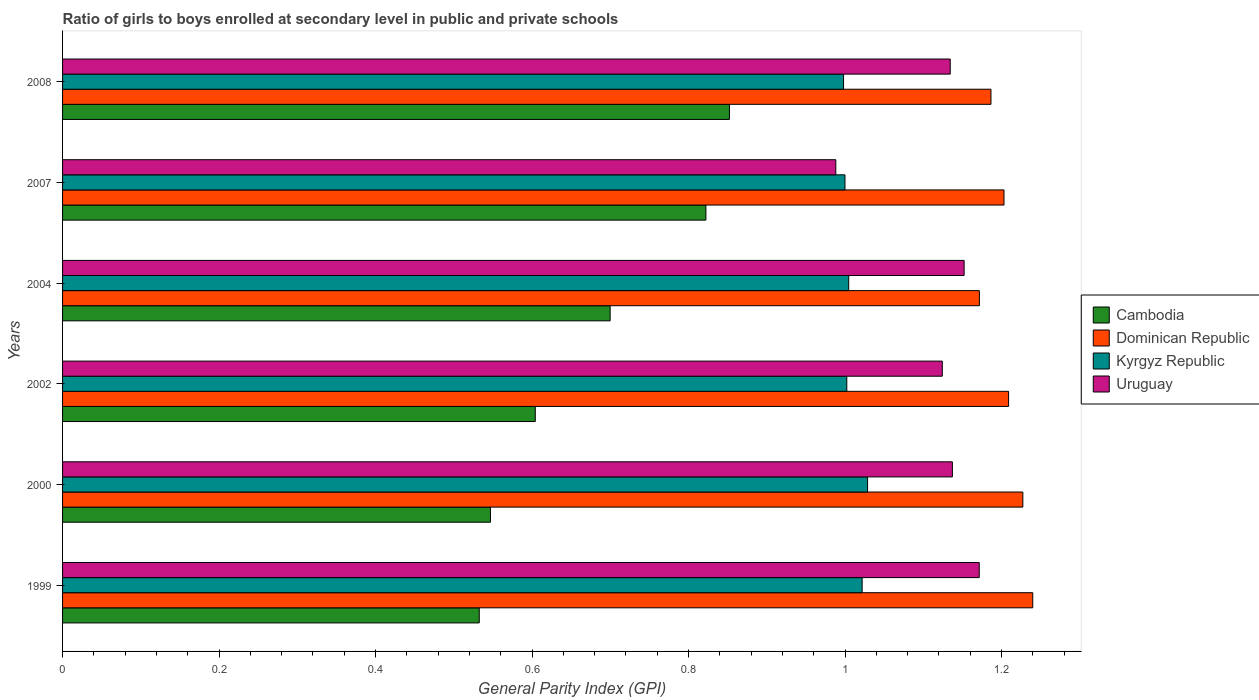How many different coloured bars are there?
Give a very brief answer. 4. Are the number of bars on each tick of the Y-axis equal?
Your response must be concise. Yes. How many bars are there on the 5th tick from the top?
Your response must be concise. 4. How many bars are there on the 1st tick from the bottom?
Provide a short and direct response. 4. What is the general parity index in Kyrgyz Republic in 1999?
Keep it short and to the point. 1.02. Across all years, what is the maximum general parity index in Cambodia?
Your response must be concise. 0.85. Across all years, what is the minimum general parity index in Cambodia?
Make the answer very short. 0.53. What is the total general parity index in Kyrgyz Republic in the graph?
Offer a very short reply. 6.06. What is the difference between the general parity index in Dominican Republic in 2002 and that in 2007?
Provide a succinct answer. 0.01. What is the difference between the general parity index in Kyrgyz Republic in 2004 and the general parity index in Uruguay in 1999?
Offer a terse response. -0.17. What is the average general parity index in Dominican Republic per year?
Offer a terse response. 1.21. In the year 2000, what is the difference between the general parity index in Dominican Republic and general parity index in Cambodia?
Make the answer very short. 0.68. In how many years, is the general parity index in Dominican Republic greater than 0.36 ?
Your answer should be compact. 6. What is the ratio of the general parity index in Dominican Republic in 2004 to that in 2008?
Give a very brief answer. 0.99. Is the general parity index in Dominican Republic in 2000 less than that in 2004?
Give a very brief answer. No. What is the difference between the highest and the second highest general parity index in Dominican Republic?
Your response must be concise. 0.01. What is the difference between the highest and the lowest general parity index in Kyrgyz Republic?
Keep it short and to the point. 0.03. In how many years, is the general parity index in Cambodia greater than the average general parity index in Cambodia taken over all years?
Keep it short and to the point. 3. Is the sum of the general parity index in Uruguay in 2004 and 2008 greater than the maximum general parity index in Dominican Republic across all years?
Provide a succinct answer. Yes. Is it the case that in every year, the sum of the general parity index in Cambodia and general parity index in Dominican Republic is greater than the sum of general parity index in Uruguay and general parity index in Kyrgyz Republic?
Offer a terse response. Yes. What does the 2nd bar from the top in 2007 represents?
Offer a very short reply. Kyrgyz Republic. What does the 3rd bar from the bottom in 2002 represents?
Give a very brief answer. Kyrgyz Republic. Is it the case that in every year, the sum of the general parity index in Dominican Republic and general parity index in Uruguay is greater than the general parity index in Cambodia?
Make the answer very short. Yes. How many bars are there?
Make the answer very short. 24. Are all the bars in the graph horizontal?
Give a very brief answer. Yes. What is the difference between two consecutive major ticks on the X-axis?
Your response must be concise. 0.2. What is the title of the graph?
Provide a short and direct response. Ratio of girls to boys enrolled at secondary level in public and private schools. What is the label or title of the X-axis?
Ensure brevity in your answer.  General Parity Index (GPI). What is the label or title of the Y-axis?
Make the answer very short. Years. What is the General Parity Index (GPI) of Cambodia in 1999?
Your response must be concise. 0.53. What is the General Parity Index (GPI) in Dominican Republic in 1999?
Your answer should be compact. 1.24. What is the General Parity Index (GPI) in Kyrgyz Republic in 1999?
Provide a short and direct response. 1.02. What is the General Parity Index (GPI) in Uruguay in 1999?
Your response must be concise. 1.17. What is the General Parity Index (GPI) in Cambodia in 2000?
Make the answer very short. 0.55. What is the General Parity Index (GPI) in Dominican Republic in 2000?
Provide a succinct answer. 1.23. What is the General Parity Index (GPI) of Kyrgyz Republic in 2000?
Keep it short and to the point. 1.03. What is the General Parity Index (GPI) of Uruguay in 2000?
Your answer should be very brief. 1.14. What is the General Parity Index (GPI) of Cambodia in 2002?
Your response must be concise. 0.6. What is the General Parity Index (GPI) of Dominican Republic in 2002?
Give a very brief answer. 1.21. What is the General Parity Index (GPI) of Kyrgyz Republic in 2002?
Provide a succinct answer. 1. What is the General Parity Index (GPI) in Uruguay in 2002?
Offer a very short reply. 1.12. What is the General Parity Index (GPI) of Cambodia in 2004?
Provide a short and direct response. 0.7. What is the General Parity Index (GPI) of Dominican Republic in 2004?
Offer a terse response. 1.17. What is the General Parity Index (GPI) in Kyrgyz Republic in 2004?
Give a very brief answer. 1. What is the General Parity Index (GPI) of Uruguay in 2004?
Your answer should be compact. 1.15. What is the General Parity Index (GPI) in Cambodia in 2007?
Your response must be concise. 0.82. What is the General Parity Index (GPI) in Dominican Republic in 2007?
Provide a short and direct response. 1.2. What is the General Parity Index (GPI) in Kyrgyz Republic in 2007?
Provide a short and direct response. 1. What is the General Parity Index (GPI) in Uruguay in 2007?
Make the answer very short. 0.99. What is the General Parity Index (GPI) in Cambodia in 2008?
Your answer should be compact. 0.85. What is the General Parity Index (GPI) of Dominican Republic in 2008?
Your answer should be very brief. 1.19. What is the General Parity Index (GPI) in Kyrgyz Republic in 2008?
Give a very brief answer. 1. What is the General Parity Index (GPI) of Uruguay in 2008?
Offer a very short reply. 1.13. Across all years, what is the maximum General Parity Index (GPI) of Cambodia?
Provide a succinct answer. 0.85. Across all years, what is the maximum General Parity Index (GPI) of Dominican Republic?
Your answer should be very brief. 1.24. Across all years, what is the maximum General Parity Index (GPI) of Kyrgyz Republic?
Your answer should be very brief. 1.03. Across all years, what is the maximum General Parity Index (GPI) in Uruguay?
Offer a terse response. 1.17. Across all years, what is the minimum General Parity Index (GPI) of Cambodia?
Keep it short and to the point. 0.53. Across all years, what is the minimum General Parity Index (GPI) in Dominican Republic?
Your answer should be very brief. 1.17. Across all years, what is the minimum General Parity Index (GPI) in Kyrgyz Republic?
Offer a terse response. 1. Across all years, what is the minimum General Parity Index (GPI) of Uruguay?
Your answer should be compact. 0.99. What is the total General Parity Index (GPI) in Cambodia in the graph?
Keep it short and to the point. 4.06. What is the total General Parity Index (GPI) of Dominican Republic in the graph?
Your response must be concise. 7.24. What is the total General Parity Index (GPI) of Kyrgyz Republic in the graph?
Your answer should be very brief. 6.06. What is the total General Parity Index (GPI) in Uruguay in the graph?
Your answer should be very brief. 6.71. What is the difference between the General Parity Index (GPI) of Cambodia in 1999 and that in 2000?
Your response must be concise. -0.01. What is the difference between the General Parity Index (GPI) of Dominican Republic in 1999 and that in 2000?
Provide a short and direct response. 0.01. What is the difference between the General Parity Index (GPI) of Kyrgyz Republic in 1999 and that in 2000?
Offer a terse response. -0.01. What is the difference between the General Parity Index (GPI) of Uruguay in 1999 and that in 2000?
Offer a very short reply. 0.03. What is the difference between the General Parity Index (GPI) of Cambodia in 1999 and that in 2002?
Provide a short and direct response. -0.07. What is the difference between the General Parity Index (GPI) in Dominican Republic in 1999 and that in 2002?
Offer a terse response. 0.03. What is the difference between the General Parity Index (GPI) of Kyrgyz Republic in 1999 and that in 2002?
Your answer should be very brief. 0.02. What is the difference between the General Parity Index (GPI) in Uruguay in 1999 and that in 2002?
Offer a very short reply. 0.05. What is the difference between the General Parity Index (GPI) of Cambodia in 1999 and that in 2004?
Give a very brief answer. -0.17. What is the difference between the General Parity Index (GPI) of Dominican Republic in 1999 and that in 2004?
Make the answer very short. 0.07. What is the difference between the General Parity Index (GPI) in Kyrgyz Republic in 1999 and that in 2004?
Make the answer very short. 0.02. What is the difference between the General Parity Index (GPI) of Uruguay in 1999 and that in 2004?
Provide a succinct answer. 0.02. What is the difference between the General Parity Index (GPI) in Cambodia in 1999 and that in 2007?
Make the answer very short. -0.29. What is the difference between the General Parity Index (GPI) in Dominican Republic in 1999 and that in 2007?
Your answer should be very brief. 0.04. What is the difference between the General Parity Index (GPI) of Kyrgyz Republic in 1999 and that in 2007?
Give a very brief answer. 0.02. What is the difference between the General Parity Index (GPI) in Uruguay in 1999 and that in 2007?
Offer a very short reply. 0.18. What is the difference between the General Parity Index (GPI) in Cambodia in 1999 and that in 2008?
Give a very brief answer. -0.32. What is the difference between the General Parity Index (GPI) of Dominican Republic in 1999 and that in 2008?
Give a very brief answer. 0.05. What is the difference between the General Parity Index (GPI) of Kyrgyz Republic in 1999 and that in 2008?
Your answer should be very brief. 0.02. What is the difference between the General Parity Index (GPI) in Uruguay in 1999 and that in 2008?
Give a very brief answer. 0.04. What is the difference between the General Parity Index (GPI) of Cambodia in 2000 and that in 2002?
Offer a terse response. -0.06. What is the difference between the General Parity Index (GPI) of Dominican Republic in 2000 and that in 2002?
Ensure brevity in your answer.  0.02. What is the difference between the General Parity Index (GPI) of Kyrgyz Republic in 2000 and that in 2002?
Offer a very short reply. 0.03. What is the difference between the General Parity Index (GPI) of Uruguay in 2000 and that in 2002?
Keep it short and to the point. 0.01. What is the difference between the General Parity Index (GPI) of Cambodia in 2000 and that in 2004?
Your answer should be compact. -0.15. What is the difference between the General Parity Index (GPI) in Dominican Republic in 2000 and that in 2004?
Keep it short and to the point. 0.06. What is the difference between the General Parity Index (GPI) of Kyrgyz Republic in 2000 and that in 2004?
Offer a very short reply. 0.02. What is the difference between the General Parity Index (GPI) of Uruguay in 2000 and that in 2004?
Keep it short and to the point. -0.01. What is the difference between the General Parity Index (GPI) of Cambodia in 2000 and that in 2007?
Ensure brevity in your answer.  -0.28. What is the difference between the General Parity Index (GPI) of Dominican Republic in 2000 and that in 2007?
Provide a succinct answer. 0.02. What is the difference between the General Parity Index (GPI) of Kyrgyz Republic in 2000 and that in 2007?
Provide a short and direct response. 0.03. What is the difference between the General Parity Index (GPI) of Uruguay in 2000 and that in 2007?
Keep it short and to the point. 0.15. What is the difference between the General Parity Index (GPI) of Cambodia in 2000 and that in 2008?
Your answer should be very brief. -0.31. What is the difference between the General Parity Index (GPI) in Dominican Republic in 2000 and that in 2008?
Offer a very short reply. 0.04. What is the difference between the General Parity Index (GPI) of Kyrgyz Republic in 2000 and that in 2008?
Make the answer very short. 0.03. What is the difference between the General Parity Index (GPI) of Uruguay in 2000 and that in 2008?
Provide a succinct answer. 0. What is the difference between the General Parity Index (GPI) in Cambodia in 2002 and that in 2004?
Offer a very short reply. -0.1. What is the difference between the General Parity Index (GPI) of Dominican Republic in 2002 and that in 2004?
Your answer should be very brief. 0.04. What is the difference between the General Parity Index (GPI) of Kyrgyz Republic in 2002 and that in 2004?
Offer a very short reply. -0. What is the difference between the General Parity Index (GPI) of Uruguay in 2002 and that in 2004?
Provide a succinct answer. -0.03. What is the difference between the General Parity Index (GPI) of Cambodia in 2002 and that in 2007?
Give a very brief answer. -0.22. What is the difference between the General Parity Index (GPI) in Dominican Republic in 2002 and that in 2007?
Offer a terse response. 0.01. What is the difference between the General Parity Index (GPI) in Kyrgyz Republic in 2002 and that in 2007?
Provide a succinct answer. 0. What is the difference between the General Parity Index (GPI) of Uruguay in 2002 and that in 2007?
Offer a terse response. 0.14. What is the difference between the General Parity Index (GPI) of Cambodia in 2002 and that in 2008?
Provide a short and direct response. -0.25. What is the difference between the General Parity Index (GPI) in Dominican Republic in 2002 and that in 2008?
Your answer should be compact. 0.02. What is the difference between the General Parity Index (GPI) in Kyrgyz Republic in 2002 and that in 2008?
Your response must be concise. 0. What is the difference between the General Parity Index (GPI) of Uruguay in 2002 and that in 2008?
Offer a terse response. -0.01. What is the difference between the General Parity Index (GPI) in Cambodia in 2004 and that in 2007?
Your answer should be very brief. -0.12. What is the difference between the General Parity Index (GPI) of Dominican Republic in 2004 and that in 2007?
Offer a terse response. -0.03. What is the difference between the General Parity Index (GPI) of Kyrgyz Republic in 2004 and that in 2007?
Make the answer very short. 0. What is the difference between the General Parity Index (GPI) in Uruguay in 2004 and that in 2007?
Offer a terse response. 0.16. What is the difference between the General Parity Index (GPI) in Cambodia in 2004 and that in 2008?
Give a very brief answer. -0.15. What is the difference between the General Parity Index (GPI) in Dominican Republic in 2004 and that in 2008?
Provide a succinct answer. -0.01. What is the difference between the General Parity Index (GPI) in Kyrgyz Republic in 2004 and that in 2008?
Your answer should be compact. 0.01. What is the difference between the General Parity Index (GPI) of Uruguay in 2004 and that in 2008?
Offer a terse response. 0.02. What is the difference between the General Parity Index (GPI) of Cambodia in 2007 and that in 2008?
Keep it short and to the point. -0.03. What is the difference between the General Parity Index (GPI) of Dominican Republic in 2007 and that in 2008?
Make the answer very short. 0.02. What is the difference between the General Parity Index (GPI) in Kyrgyz Republic in 2007 and that in 2008?
Make the answer very short. 0. What is the difference between the General Parity Index (GPI) of Uruguay in 2007 and that in 2008?
Your response must be concise. -0.15. What is the difference between the General Parity Index (GPI) of Cambodia in 1999 and the General Parity Index (GPI) of Dominican Republic in 2000?
Offer a terse response. -0.69. What is the difference between the General Parity Index (GPI) in Cambodia in 1999 and the General Parity Index (GPI) in Kyrgyz Republic in 2000?
Give a very brief answer. -0.5. What is the difference between the General Parity Index (GPI) in Cambodia in 1999 and the General Parity Index (GPI) in Uruguay in 2000?
Your response must be concise. -0.6. What is the difference between the General Parity Index (GPI) of Dominican Republic in 1999 and the General Parity Index (GPI) of Kyrgyz Republic in 2000?
Your answer should be very brief. 0.21. What is the difference between the General Parity Index (GPI) of Dominican Republic in 1999 and the General Parity Index (GPI) of Uruguay in 2000?
Make the answer very short. 0.1. What is the difference between the General Parity Index (GPI) in Kyrgyz Republic in 1999 and the General Parity Index (GPI) in Uruguay in 2000?
Ensure brevity in your answer.  -0.12. What is the difference between the General Parity Index (GPI) in Cambodia in 1999 and the General Parity Index (GPI) in Dominican Republic in 2002?
Your answer should be very brief. -0.68. What is the difference between the General Parity Index (GPI) of Cambodia in 1999 and the General Parity Index (GPI) of Kyrgyz Republic in 2002?
Provide a succinct answer. -0.47. What is the difference between the General Parity Index (GPI) of Cambodia in 1999 and the General Parity Index (GPI) of Uruguay in 2002?
Your answer should be compact. -0.59. What is the difference between the General Parity Index (GPI) of Dominican Republic in 1999 and the General Parity Index (GPI) of Kyrgyz Republic in 2002?
Give a very brief answer. 0.24. What is the difference between the General Parity Index (GPI) of Dominican Republic in 1999 and the General Parity Index (GPI) of Uruguay in 2002?
Ensure brevity in your answer.  0.12. What is the difference between the General Parity Index (GPI) of Kyrgyz Republic in 1999 and the General Parity Index (GPI) of Uruguay in 2002?
Make the answer very short. -0.1. What is the difference between the General Parity Index (GPI) in Cambodia in 1999 and the General Parity Index (GPI) in Dominican Republic in 2004?
Ensure brevity in your answer.  -0.64. What is the difference between the General Parity Index (GPI) in Cambodia in 1999 and the General Parity Index (GPI) in Kyrgyz Republic in 2004?
Provide a short and direct response. -0.47. What is the difference between the General Parity Index (GPI) in Cambodia in 1999 and the General Parity Index (GPI) in Uruguay in 2004?
Your answer should be very brief. -0.62. What is the difference between the General Parity Index (GPI) in Dominican Republic in 1999 and the General Parity Index (GPI) in Kyrgyz Republic in 2004?
Keep it short and to the point. 0.24. What is the difference between the General Parity Index (GPI) in Dominican Republic in 1999 and the General Parity Index (GPI) in Uruguay in 2004?
Give a very brief answer. 0.09. What is the difference between the General Parity Index (GPI) in Kyrgyz Republic in 1999 and the General Parity Index (GPI) in Uruguay in 2004?
Make the answer very short. -0.13. What is the difference between the General Parity Index (GPI) in Cambodia in 1999 and the General Parity Index (GPI) in Dominican Republic in 2007?
Provide a short and direct response. -0.67. What is the difference between the General Parity Index (GPI) in Cambodia in 1999 and the General Parity Index (GPI) in Kyrgyz Republic in 2007?
Your answer should be very brief. -0.47. What is the difference between the General Parity Index (GPI) in Cambodia in 1999 and the General Parity Index (GPI) in Uruguay in 2007?
Provide a succinct answer. -0.46. What is the difference between the General Parity Index (GPI) in Dominican Republic in 1999 and the General Parity Index (GPI) in Kyrgyz Republic in 2007?
Your response must be concise. 0.24. What is the difference between the General Parity Index (GPI) of Dominican Republic in 1999 and the General Parity Index (GPI) of Uruguay in 2007?
Provide a succinct answer. 0.25. What is the difference between the General Parity Index (GPI) in Kyrgyz Republic in 1999 and the General Parity Index (GPI) in Uruguay in 2007?
Your response must be concise. 0.03. What is the difference between the General Parity Index (GPI) in Cambodia in 1999 and the General Parity Index (GPI) in Dominican Republic in 2008?
Offer a terse response. -0.65. What is the difference between the General Parity Index (GPI) in Cambodia in 1999 and the General Parity Index (GPI) in Kyrgyz Republic in 2008?
Your answer should be very brief. -0.47. What is the difference between the General Parity Index (GPI) in Cambodia in 1999 and the General Parity Index (GPI) in Uruguay in 2008?
Your response must be concise. -0.6. What is the difference between the General Parity Index (GPI) in Dominican Republic in 1999 and the General Parity Index (GPI) in Kyrgyz Republic in 2008?
Provide a succinct answer. 0.24. What is the difference between the General Parity Index (GPI) of Dominican Republic in 1999 and the General Parity Index (GPI) of Uruguay in 2008?
Offer a terse response. 0.11. What is the difference between the General Parity Index (GPI) in Kyrgyz Republic in 1999 and the General Parity Index (GPI) in Uruguay in 2008?
Give a very brief answer. -0.11. What is the difference between the General Parity Index (GPI) in Cambodia in 2000 and the General Parity Index (GPI) in Dominican Republic in 2002?
Provide a succinct answer. -0.66. What is the difference between the General Parity Index (GPI) in Cambodia in 2000 and the General Parity Index (GPI) in Kyrgyz Republic in 2002?
Keep it short and to the point. -0.46. What is the difference between the General Parity Index (GPI) in Cambodia in 2000 and the General Parity Index (GPI) in Uruguay in 2002?
Your answer should be compact. -0.58. What is the difference between the General Parity Index (GPI) of Dominican Republic in 2000 and the General Parity Index (GPI) of Kyrgyz Republic in 2002?
Keep it short and to the point. 0.23. What is the difference between the General Parity Index (GPI) of Dominican Republic in 2000 and the General Parity Index (GPI) of Uruguay in 2002?
Your answer should be very brief. 0.1. What is the difference between the General Parity Index (GPI) in Kyrgyz Republic in 2000 and the General Parity Index (GPI) in Uruguay in 2002?
Give a very brief answer. -0.1. What is the difference between the General Parity Index (GPI) in Cambodia in 2000 and the General Parity Index (GPI) in Dominican Republic in 2004?
Keep it short and to the point. -0.62. What is the difference between the General Parity Index (GPI) of Cambodia in 2000 and the General Parity Index (GPI) of Kyrgyz Republic in 2004?
Offer a very short reply. -0.46. What is the difference between the General Parity Index (GPI) in Cambodia in 2000 and the General Parity Index (GPI) in Uruguay in 2004?
Ensure brevity in your answer.  -0.61. What is the difference between the General Parity Index (GPI) of Dominican Republic in 2000 and the General Parity Index (GPI) of Kyrgyz Republic in 2004?
Offer a terse response. 0.22. What is the difference between the General Parity Index (GPI) in Dominican Republic in 2000 and the General Parity Index (GPI) in Uruguay in 2004?
Give a very brief answer. 0.07. What is the difference between the General Parity Index (GPI) in Kyrgyz Republic in 2000 and the General Parity Index (GPI) in Uruguay in 2004?
Provide a succinct answer. -0.12. What is the difference between the General Parity Index (GPI) of Cambodia in 2000 and the General Parity Index (GPI) of Dominican Republic in 2007?
Provide a succinct answer. -0.66. What is the difference between the General Parity Index (GPI) of Cambodia in 2000 and the General Parity Index (GPI) of Kyrgyz Republic in 2007?
Your answer should be compact. -0.45. What is the difference between the General Parity Index (GPI) of Cambodia in 2000 and the General Parity Index (GPI) of Uruguay in 2007?
Give a very brief answer. -0.44. What is the difference between the General Parity Index (GPI) in Dominican Republic in 2000 and the General Parity Index (GPI) in Kyrgyz Republic in 2007?
Your response must be concise. 0.23. What is the difference between the General Parity Index (GPI) of Dominican Republic in 2000 and the General Parity Index (GPI) of Uruguay in 2007?
Ensure brevity in your answer.  0.24. What is the difference between the General Parity Index (GPI) in Kyrgyz Republic in 2000 and the General Parity Index (GPI) in Uruguay in 2007?
Give a very brief answer. 0.04. What is the difference between the General Parity Index (GPI) of Cambodia in 2000 and the General Parity Index (GPI) of Dominican Republic in 2008?
Give a very brief answer. -0.64. What is the difference between the General Parity Index (GPI) of Cambodia in 2000 and the General Parity Index (GPI) of Kyrgyz Republic in 2008?
Ensure brevity in your answer.  -0.45. What is the difference between the General Parity Index (GPI) of Cambodia in 2000 and the General Parity Index (GPI) of Uruguay in 2008?
Offer a terse response. -0.59. What is the difference between the General Parity Index (GPI) of Dominican Republic in 2000 and the General Parity Index (GPI) of Kyrgyz Republic in 2008?
Keep it short and to the point. 0.23. What is the difference between the General Parity Index (GPI) in Dominican Republic in 2000 and the General Parity Index (GPI) in Uruguay in 2008?
Make the answer very short. 0.09. What is the difference between the General Parity Index (GPI) of Kyrgyz Republic in 2000 and the General Parity Index (GPI) of Uruguay in 2008?
Give a very brief answer. -0.11. What is the difference between the General Parity Index (GPI) in Cambodia in 2002 and the General Parity Index (GPI) in Dominican Republic in 2004?
Offer a very short reply. -0.57. What is the difference between the General Parity Index (GPI) of Cambodia in 2002 and the General Parity Index (GPI) of Kyrgyz Republic in 2004?
Offer a very short reply. -0.4. What is the difference between the General Parity Index (GPI) of Cambodia in 2002 and the General Parity Index (GPI) of Uruguay in 2004?
Your answer should be compact. -0.55. What is the difference between the General Parity Index (GPI) of Dominican Republic in 2002 and the General Parity Index (GPI) of Kyrgyz Republic in 2004?
Provide a succinct answer. 0.2. What is the difference between the General Parity Index (GPI) in Dominican Republic in 2002 and the General Parity Index (GPI) in Uruguay in 2004?
Offer a terse response. 0.06. What is the difference between the General Parity Index (GPI) in Kyrgyz Republic in 2002 and the General Parity Index (GPI) in Uruguay in 2004?
Your response must be concise. -0.15. What is the difference between the General Parity Index (GPI) in Cambodia in 2002 and the General Parity Index (GPI) in Dominican Republic in 2007?
Your answer should be compact. -0.6. What is the difference between the General Parity Index (GPI) of Cambodia in 2002 and the General Parity Index (GPI) of Kyrgyz Republic in 2007?
Ensure brevity in your answer.  -0.4. What is the difference between the General Parity Index (GPI) of Cambodia in 2002 and the General Parity Index (GPI) of Uruguay in 2007?
Offer a very short reply. -0.38. What is the difference between the General Parity Index (GPI) of Dominican Republic in 2002 and the General Parity Index (GPI) of Kyrgyz Republic in 2007?
Your answer should be compact. 0.21. What is the difference between the General Parity Index (GPI) in Dominican Republic in 2002 and the General Parity Index (GPI) in Uruguay in 2007?
Your response must be concise. 0.22. What is the difference between the General Parity Index (GPI) in Kyrgyz Republic in 2002 and the General Parity Index (GPI) in Uruguay in 2007?
Make the answer very short. 0.01. What is the difference between the General Parity Index (GPI) in Cambodia in 2002 and the General Parity Index (GPI) in Dominican Republic in 2008?
Offer a very short reply. -0.58. What is the difference between the General Parity Index (GPI) in Cambodia in 2002 and the General Parity Index (GPI) in Kyrgyz Republic in 2008?
Make the answer very short. -0.39. What is the difference between the General Parity Index (GPI) in Cambodia in 2002 and the General Parity Index (GPI) in Uruguay in 2008?
Provide a succinct answer. -0.53. What is the difference between the General Parity Index (GPI) in Dominican Republic in 2002 and the General Parity Index (GPI) in Kyrgyz Republic in 2008?
Your answer should be very brief. 0.21. What is the difference between the General Parity Index (GPI) of Dominican Republic in 2002 and the General Parity Index (GPI) of Uruguay in 2008?
Offer a very short reply. 0.07. What is the difference between the General Parity Index (GPI) in Kyrgyz Republic in 2002 and the General Parity Index (GPI) in Uruguay in 2008?
Offer a very short reply. -0.13. What is the difference between the General Parity Index (GPI) of Cambodia in 2004 and the General Parity Index (GPI) of Dominican Republic in 2007?
Provide a succinct answer. -0.5. What is the difference between the General Parity Index (GPI) of Cambodia in 2004 and the General Parity Index (GPI) of Kyrgyz Republic in 2007?
Give a very brief answer. -0.3. What is the difference between the General Parity Index (GPI) in Cambodia in 2004 and the General Parity Index (GPI) in Uruguay in 2007?
Keep it short and to the point. -0.29. What is the difference between the General Parity Index (GPI) in Dominican Republic in 2004 and the General Parity Index (GPI) in Kyrgyz Republic in 2007?
Make the answer very short. 0.17. What is the difference between the General Parity Index (GPI) of Dominican Republic in 2004 and the General Parity Index (GPI) of Uruguay in 2007?
Give a very brief answer. 0.18. What is the difference between the General Parity Index (GPI) in Kyrgyz Republic in 2004 and the General Parity Index (GPI) in Uruguay in 2007?
Provide a succinct answer. 0.02. What is the difference between the General Parity Index (GPI) of Cambodia in 2004 and the General Parity Index (GPI) of Dominican Republic in 2008?
Your answer should be very brief. -0.49. What is the difference between the General Parity Index (GPI) in Cambodia in 2004 and the General Parity Index (GPI) in Kyrgyz Republic in 2008?
Give a very brief answer. -0.3. What is the difference between the General Parity Index (GPI) of Cambodia in 2004 and the General Parity Index (GPI) of Uruguay in 2008?
Offer a very short reply. -0.43. What is the difference between the General Parity Index (GPI) of Dominican Republic in 2004 and the General Parity Index (GPI) of Kyrgyz Republic in 2008?
Provide a succinct answer. 0.17. What is the difference between the General Parity Index (GPI) of Dominican Republic in 2004 and the General Parity Index (GPI) of Uruguay in 2008?
Offer a very short reply. 0.04. What is the difference between the General Parity Index (GPI) of Kyrgyz Republic in 2004 and the General Parity Index (GPI) of Uruguay in 2008?
Your answer should be very brief. -0.13. What is the difference between the General Parity Index (GPI) of Cambodia in 2007 and the General Parity Index (GPI) of Dominican Republic in 2008?
Your response must be concise. -0.36. What is the difference between the General Parity Index (GPI) of Cambodia in 2007 and the General Parity Index (GPI) of Kyrgyz Republic in 2008?
Keep it short and to the point. -0.18. What is the difference between the General Parity Index (GPI) of Cambodia in 2007 and the General Parity Index (GPI) of Uruguay in 2008?
Keep it short and to the point. -0.31. What is the difference between the General Parity Index (GPI) in Dominican Republic in 2007 and the General Parity Index (GPI) in Kyrgyz Republic in 2008?
Give a very brief answer. 0.2. What is the difference between the General Parity Index (GPI) of Dominican Republic in 2007 and the General Parity Index (GPI) of Uruguay in 2008?
Provide a succinct answer. 0.07. What is the difference between the General Parity Index (GPI) of Kyrgyz Republic in 2007 and the General Parity Index (GPI) of Uruguay in 2008?
Offer a very short reply. -0.13. What is the average General Parity Index (GPI) in Cambodia per year?
Provide a short and direct response. 0.68. What is the average General Parity Index (GPI) of Dominican Republic per year?
Keep it short and to the point. 1.21. What is the average General Parity Index (GPI) of Kyrgyz Republic per year?
Ensure brevity in your answer.  1.01. What is the average General Parity Index (GPI) in Uruguay per year?
Offer a very short reply. 1.12. In the year 1999, what is the difference between the General Parity Index (GPI) in Cambodia and General Parity Index (GPI) in Dominican Republic?
Make the answer very short. -0.71. In the year 1999, what is the difference between the General Parity Index (GPI) in Cambodia and General Parity Index (GPI) in Kyrgyz Republic?
Offer a terse response. -0.49. In the year 1999, what is the difference between the General Parity Index (GPI) of Cambodia and General Parity Index (GPI) of Uruguay?
Make the answer very short. -0.64. In the year 1999, what is the difference between the General Parity Index (GPI) in Dominican Republic and General Parity Index (GPI) in Kyrgyz Republic?
Your response must be concise. 0.22. In the year 1999, what is the difference between the General Parity Index (GPI) in Dominican Republic and General Parity Index (GPI) in Uruguay?
Your response must be concise. 0.07. In the year 1999, what is the difference between the General Parity Index (GPI) in Kyrgyz Republic and General Parity Index (GPI) in Uruguay?
Your answer should be compact. -0.15. In the year 2000, what is the difference between the General Parity Index (GPI) in Cambodia and General Parity Index (GPI) in Dominican Republic?
Your response must be concise. -0.68. In the year 2000, what is the difference between the General Parity Index (GPI) of Cambodia and General Parity Index (GPI) of Kyrgyz Republic?
Offer a terse response. -0.48. In the year 2000, what is the difference between the General Parity Index (GPI) of Cambodia and General Parity Index (GPI) of Uruguay?
Offer a terse response. -0.59. In the year 2000, what is the difference between the General Parity Index (GPI) of Dominican Republic and General Parity Index (GPI) of Kyrgyz Republic?
Ensure brevity in your answer.  0.2. In the year 2000, what is the difference between the General Parity Index (GPI) of Dominican Republic and General Parity Index (GPI) of Uruguay?
Ensure brevity in your answer.  0.09. In the year 2000, what is the difference between the General Parity Index (GPI) in Kyrgyz Republic and General Parity Index (GPI) in Uruguay?
Give a very brief answer. -0.11. In the year 2002, what is the difference between the General Parity Index (GPI) of Cambodia and General Parity Index (GPI) of Dominican Republic?
Offer a terse response. -0.6. In the year 2002, what is the difference between the General Parity Index (GPI) of Cambodia and General Parity Index (GPI) of Kyrgyz Republic?
Your answer should be compact. -0.4. In the year 2002, what is the difference between the General Parity Index (GPI) of Cambodia and General Parity Index (GPI) of Uruguay?
Provide a succinct answer. -0.52. In the year 2002, what is the difference between the General Parity Index (GPI) of Dominican Republic and General Parity Index (GPI) of Kyrgyz Republic?
Ensure brevity in your answer.  0.21. In the year 2002, what is the difference between the General Parity Index (GPI) in Dominican Republic and General Parity Index (GPI) in Uruguay?
Keep it short and to the point. 0.08. In the year 2002, what is the difference between the General Parity Index (GPI) in Kyrgyz Republic and General Parity Index (GPI) in Uruguay?
Provide a short and direct response. -0.12. In the year 2004, what is the difference between the General Parity Index (GPI) of Cambodia and General Parity Index (GPI) of Dominican Republic?
Provide a succinct answer. -0.47. In the year 2004, what is the difference between the General Parity Index (GPI) of Cambodia and General Parity Index (GPI) of Kyrgyz Republic?
Your answer should be compact. -0.3. In the year 2004, what is the difference between the General Parity Index (GPI) in Cambodia and General Parity Index (GPI) in Uruguay?
Provide a short and direct response. -0.45. In the year 2004, what is the difference between the General Parity Index (GPI) of Dominican Republic and General Parity Index (GPI) of Kyrgyz Republic?
Offer a terse response. 0.17. In the year 2004, what is the difference between the General Parity Index (GPI) in Dominican Republic and General Parity Index (GPI) in Uruguay?
Your answer should be compact. 0.02. In the year 2004, what is the difference between the General Parity Index (GPI) of Kyrgyz Republic and General Parity Index (GPI) of Uruguay?
Your answer should be compact. -0.15. In the year 2007, what is the difference between the General Parity Index (GPI) of Cambodia and General Parity Index (GPI) of Dominican Republic?
Provide a short and direct response. -0.38. In the year 2007, what is the difference between the General Parity Index (GPI) of Cambodia and General Parity Index (GPI) of Kyrgyz Republic?
Offer a very short reply. -0.18. In the year 2007, what is the difference between the General Parity Index (GPI) in Cambodia and General Parity Index (GPI) in Uruguay?
Make the answer very short. -0.17. In the year 2007, what is the difference between the General Parity Index (GPI) of Dominican Republic and General Parity Index (GPI) of Kyrgyz Republic?
Ensure brevity in your answer.  0.2. In the year 2007, what is the difference between the General Parity Index (GPI) in Dominican Republic and General Parity Index (GPI) in Uruguay?
Your answer should be compact. 0.21. In the year 2007, what is the difference between the General Parity Index (GPI) in Kyrgyz Republic and General Parity Index (GPI) in Uruguay?
Keep it short and to the point. 0.01. In the year 2008, what is the difference between the General Parity Index (GPI) of Cambodia and General Parity Index (GPI) of Dominican Republic?
Keep it short and to the point. -0.33. In the year 2008, what is the difference between the General Parity Index (GPI) in Cambodia and General Parity Index (GPI) in Kyrgyz Republic?
Offer a very short reply. -0.15. In the year 2008, what is the difference between the General Parity Index (GPI) of Cambodia and General Parity Index (GPI) of Uruguay?
Provide a succinct answer. -0.28. In the year 2008, what is the difference between the General Parity Index (GPI) of Dominican Republic and General Parity Index (GPI) of Kyrgyz Republic?
Offer a terse response. 0.19. In the year 2008, what is the difference between the General Parity Index (GPI) of Dominican Republic and General Parity Index (GPI) of Uruguay?
Provide a short and direct response. 0.05. In the year 2008, what is the difference between the General Parity Index (GPI) of Kyrgyz Republic and General Parity Index (GPI) of Uruguay?
Your answer should be compact. -0.14. What is the ratio of the General Parity Index (GPI) in Cambodia in 1999 to that in 2000?
Offer a terse response. 0.97. What is the ratio of the General Parity Index (GPI) in Dominican Republic in 1999 to that in 2000?
Your answer should be very brief. 1.01. What is the ratio of the General Parity Index (GPI) of Uruguay in 1999 to that in 2000?
Give a very brief answer. 1.03. What is the ratio of the General Parity Index (GPI) in Cambodia in 1999 to that in 2002?
Ensure brevity in your answer.  0.88. What is the ratio of the General Parity Index (GPI) of Dominican Republic in 1999 to that in 2002?
Your answer should be very brief. 1.03. What is the ratio of the General Parity Index (GPI) of Kyrgyz Republic in 1999 to that in 2002?
Offer a terse response. 1.02. What is the ratio of the General Parity Index (GPI) of Uruguay in 1999 to that in 2002?
Provide a short and direct response. 1.04. What is the ratio of the General Parity Index (GPI) in Cambodia in 1999 to that in 2004?
Give a very brief answer. 0.76. What is the ratio of the General Parity Index (GPI) of Dominican Republic in 1999 to that in 2004?
Provide a short and direct response. 1.06. What is the ratio of the General Parity Index (GPI) in Kyrgyz Republic in 1999 to that in 2004?
Ensure brevity in your answer.  1.02. What is the ratio of the General Parity Index (GPI) of Uruguay in 1999 to that in 2004?
Your response must be concise. 1.02. What is the ratio of the General Parity Index (GPI) of Cambodia in 1999 to that in 2007?
Provide a short and direct response. 0.65. What is the ratio of the General Parity Index (GPI) of Dominican Republic in 1999 to that in 2007?
Make the answer very short. 1.03. What is the ratio of the General Parity Index (GPI) in Kyrgyz Republic in 1999 to that in 2007?
Your answer should be compact. 1.02. What is the ratio of the General Parity Index (GPI) in Uruguay in 1999 to that in 2007?
Your answer should be very brief. 1.19. What is the ratio of the General Parity Index (GPI) in Cambodia in 1999 to that in 2008?
Offer a very short reply. 0.62. What is the ratio of the General Parity Index (GPI) of Dominican Republic in 1999 to that in 2008?
Offer a very short reply. 1.04. What is the ratio of the General Parity Index (GPI) of Kyrgyz Republic in 1999 to that in 2008?
Keep it short and to the point. 1.02. What is the ratio of the General Parity Index (GPI) of Uruguay in 1999 to that in 2008?
Provide a short and direct response. 1.03. What is the ratio of the General Parity Index (GPI) in Cambodia in 2000 to that in 2002?
Make the answer very short. 0.91. What is the ratio of the General Parity Index (GPI) of Dominican Republic in 2000 to that in 2002?
Provide a short and direct response. 1.02. What is the ratio of the General Parity Index (GPI) of Kyrgyz Republic in 2000 to that in 2002?
Give a very brief answer. 1.03. What is the ratio of the General Parity Index (GPI) of Uruguay in 2000 to that in 2002?
Offer a terse response. 1.01. What is the ratio of the General Parity Index (GPI) in Cambodia in 2000 to that in 2004?
Your response must be concise. 0.78. What is the ratio of the General Parity Index (GPI) of Dominican Republic in 2000 to that in 2004?
Give a very brief answer. 1.05. What is the ratio of the General Parity Index (GPI) of Kyrgyz Republic in 2000 to that in 2004?
Offer a very short reply. 1.02. What is the ratio of the General Parity Index (GPI) in Uruguay in 2000 to that in 2004?
Make the answer very short. 0.99. What is the ratio of the General Parity Index (GPI) of Cambodia in 2000 to that in 2007?
Offer a very short reply. 0.67. What is the ratio of the General Parity Index (GPI) in Dominican Republic in 2000 to that in 2007?
Provide a succinct answer. 1.02. What is the ratio of the General Parity Index (GPI) in Kyrgyz Republic in 2000 to that in 2007?
Your answer should be very brief. 1.03. What is the ratio of the General Parity Index (GPI) in Uruguay in 2000 to that in 2007?
Provide a succinct answer. 1.15. What is the ratio of the General Parity Index (GPI) of Cambodia in 2000 to that in 2008?
Offer a terse response. 0.64. What is the ratio of the General Parity Index (GPI) in Dominican Republic in 2000 to that in 2008?
Your response must be concise. 1.03. What is the ratio of the General Parity Index (GPI) in Kyrgyz Republic in 2000 to that in 2008?
Provide a succinct answer. 1.03. What is the ratio of the General Parity Index (GPI) of Cambodia in 2002 to that in 2004?
Provide a succinct answer. 0.86. What is the ratio of the General Parity Index (GPI) of Dominican Republic in 2002 to that in 2004?
Provide a succinct answer. 1.03. What is the ratio of the General Parity Index (GPI) of Kyrgyz Republic in 2002 to that in 2004?
Provide a succinct answer. 1. What is the ratio of the General Parity Index (GPI) in Uruguay in 2002 to that in 2004?
Offer a terse response. 0.98. What is the ratio of the General Parity Index (GPI) in Cambodia in 2002 to that in 2007?
Give a very brief answer. 0.73. What is the ratio of the General Parity Index (GPI) of Uruguay in 2002 to that in 2007?
Ensure brevity in your answer.  1.14. What is the ratio of the General Parity Index (GPI) in Cambodia in 2002 to that in 2008?
Provide a succinct answer. 0.71. What is the ratio of the General Parity Index (GPI) of Dominican Republic in 2002 to that in 2008?
Your answer should be very brief. 1.02. What is the ratio of the General Parity Index (GPI) of Uruguay in 2002 to that in 2008?
Ensure brevity in your answer.  0.99. What is the ratio of the General Parity Index (GPI) of Cambodia in 2004 to that in 2007?
Your answer should be compact. 0.85. What is the ratio of the General Parity Index (GPI) of Dominican Republic in 2004 to that in 2007?
Provide a short and direct response. 0.97. What is the ratio of the General Parity Index (GPI) of Uruguay in 2004 to that in 2007?
Your answer should be compact. 1.17. What is the ratio of the General Parity Index (GPI) of Cambodia in 2004 to that in 2008?
Provide a short and direct response. 0.82. What is the ratio of the General Parity Index (GPI) in Dominican Republic in 2004 to that in 2008?
Provide a short and direct response. 0.99. What is the ratio of the General Parity Index (GPI) in Kyrgyz Republic in 2004 to that in 2008?
Offer a terse response. 1.01. What is the ratio of the General Parity Index (GPI) of Uruguay in 2004 to that in 2008?
Your answer should be compact. 1.02. What is the ratio of the General Parity Index (GPI) in Cambodia in 2007 to that in 2008?
Provide a succinct answer. 0.96. What is the ratio of the General Parity Index (GPI) in Dominican Republic in 2007 to that in 2008?
Provide a succinct answer. 1.01. What is the ratio of the General Parity Index (GPI) of Uruguay in 2007 to that in 2008?
Keep it short and to the point. 0.87. What is the difference between the highest and the second highest General Parity Index (GPI) of Cambodia?
Make the answer very short. 0.03. What is the difference between the highest and the second highest General Parity Index (GPI) of Dominican Republic?
Give a very brief answer. 0.01. What is the difference between the highest and the second highest General Parity Index (GPI) of Kyrgyz Republic?
Make the answer very short. 0.01. What is the difference between the highest and the second highest General Parity Index (GPI) of Uruguay?
Offer a terse response. 0.02. What is the difference between the highest and the lowest General Parity Index (GPI) of Cambodia?
Ensure brevity in your answer.  0.32. What is the difference between the highest and the lowest General Parity Index (GPI) in Dominican Republic?
Make the answer very short. 0.07. What is the difference between the highest and the lowest General Parity Index (GPI) in Kyrgyz Republic?
Your response must be concise. 0.03. What is the difference between the highest and the lowest General Parity Index (GPI) of Uruguay?
Keep it short and to the point. 0.18. 